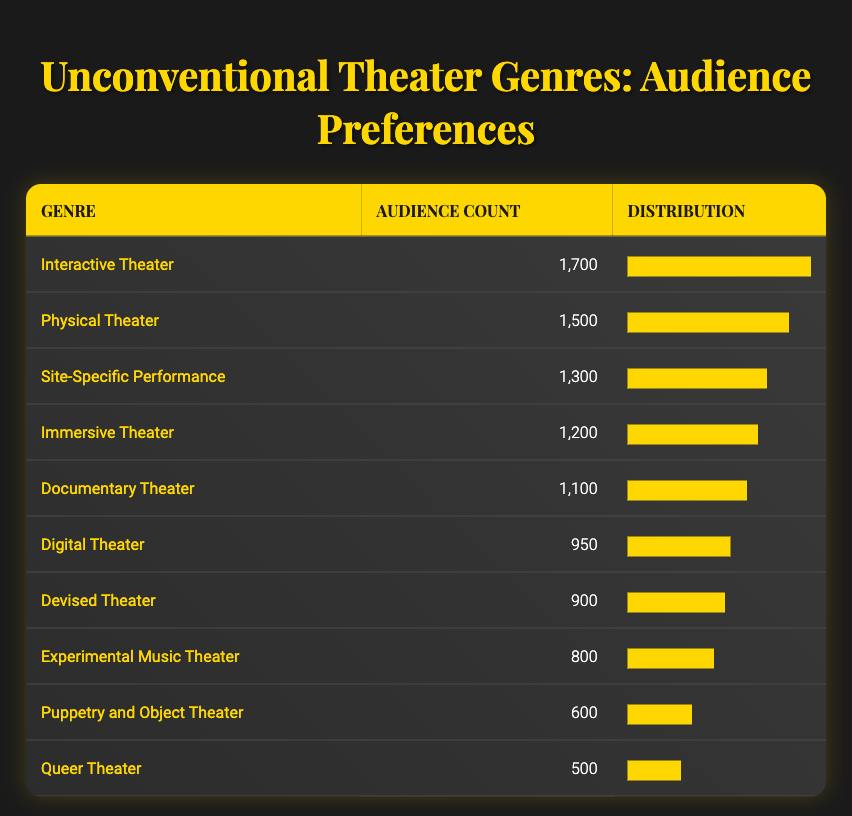What is the audience count for Interactive Theater? The audience count for Interactive Theater is directly stated in the table under the "Audience Count" column as 1,700.
Answer: 1700 Which unconventional genre has the least audience count? By examining the "Audience Count" column, the lowest number is found for Queer Theater, which has an audience count of 500.
Answer: Queer Theater What is the total audience count for the top three unconventional theater genres? To find the total, we add the audience counts for the top three genres: Interactive Theater (1,700) + Physical Theater (1,500) + Site-Specific Performance (1,300) = 4,500.
Answer: 4500 Is the audience count for Digital Theater greater than that for Devised Theater? Comparing the audience counts reveals that Digital Theater has 950 and Devised Theater has 900, so 950 is indeed greater than 900.
Answer: Yes What percentage of the audience prefers Physical Theater compared to the total audience for all genres listed? First, calculate the total audience count, which is 1500 + 1300 + 1700 + 1200 + 800 + 600 + 900 + 1100 + 950 + 500 = 10600. Then, divide the audience count for Physical Theater (1,500) by the total (10,600) and multiply by 100 to get the percentage: (1500 / 10600) * 100 = 14.15%.
Answer: 14.15% Which genre has an audience count greater than 1,000, but less than 1,500? Analyzing the "Audience Count" column, we see that both Documentary Theater (1,100) and Immersive Theater (1,200) fit this criteria because they are over 1,000 but under 1,500.
Answer: Documentary Theater and Immersive Theater If we combine the audience counts for the top five genres, what is the new total? Adding the audience counts for the top five genres: Interactive Theater (1,700) + Physical Theater (1,500) + Site-Specific Performance (1,300) + Immersive Theater (1,200) + Documentary Theater (1,100) = 6,800.
Answer: 6800 Are there more people in the audience for Immersive Theater than for Puppetry and Object Theater? Immersive Theater has an audience of 1,200 while Puppetry and Object Theater has 600, which indicates that the audience for Immersive Theater is indeed larger.
Answer: Yes What is the median audience count of the listed unconventional theater genres? To find the median, first list the audience counts in order: 500, 600, 800, 900, 950, 1100, 1200, 1300, 1500, 1700. The middle values (fifth and sixth) are 950 and 1100. The median is then (950 + 1100) / 2 = 1025.
Answer: 1025 